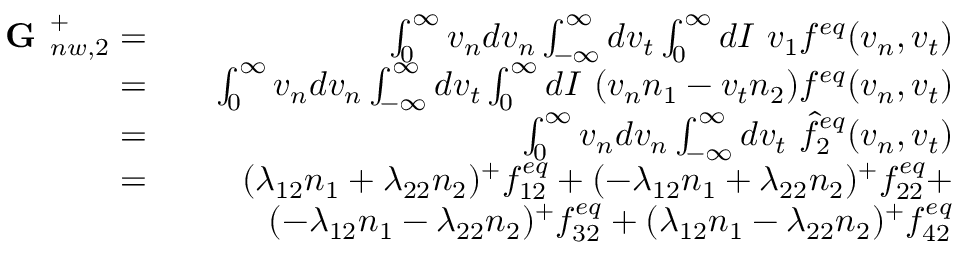<formula> <loc_0><loc_0><loc_500><loc_500>\begin{array} { r l r } { G _ { n w , 2 } ^ { + } = } & { \int _ { 0 } ^ { \infty } v _ { n } d v _ { n } \int _ { - \infty } ^ { \infty } d v _ { t } \int _ { 0 } ^ { \infty } d I \ v _ { 1 } f ^ { e q } ( v _ { n } , v _ { t } ) } \\ { = } & { \int _ { 0 } ^ { \infty } v _ { n } d v _ { n } \int _ { - \infty } ^ { \infty } d v _ { t } \int _ { 0 } ^ { \infty } d I \ ( v _ { n } n _ { 1 } - v _ { t } n _ { 2 } ) f ^ { e q } ( v _ { n } , v _ { t } ) } \\ { = } & { \int _ { 0 } ^ { \infty } v _ { n } d v _ { n } \int _ { - \infty } ^ { \infty } d v _ { t } \ \hat { f } _ { 2 } ^ { e q } ( v _ { n } , v _ { t } ) } \\ { = } & { ( \lambda _ { 1 2 } n _ { 1 } + \lambda _ { 2 2 } n _ { 2 } ) ^ { + } f _ { 1 2 } ^ { e q } + ( - \lambda _ { 1 2 } n _ { 1 } + \lambda _ { 2 2 } n _ { 2 } ) ^ { + } f _ { 2 2 } ^ { e q } + } \\ & { ( - \lambda _ { 1 2 } n _ { 1 } - \lambda _ { 2 2 } n _ { 2 } ) ^ { + } f _ { 3 2 } ^ { e q } + ( \lambda _ { 1 2 } n _ { 1 } - \lambda _ { 2 2 } n _ { 2 } ) ^ { + } f _ { 4 2 } ^ { e q } } \end{array}</formula> 